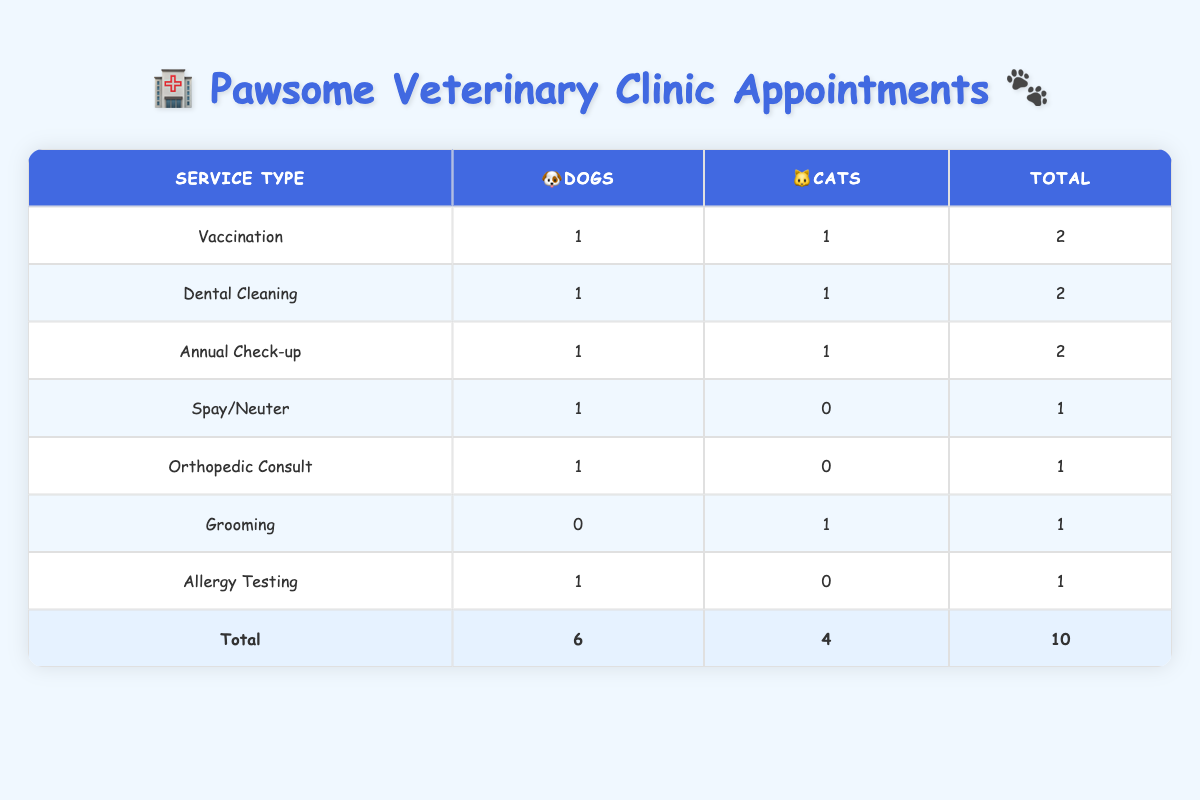What is the total number of appointments for dogs? To find the total number of appointments for dogs, I observe the 'Dogs' column in each row of the table. By summing the values of the 'Dogs' column: 1 (Vaccination) + 1 (Annual Check-up) + 1 (Spay/Neuter) + 1 (Orthopedic Consult) + 1 (Allergy Testing) = 5.
Answer: 5 How many cats had dental cleaning appointments? I look at the 'Cats' column specifically for the 'Dental Cleaning' row in the table. It shows 1 appointment for cats under that service type.
Answer: 1 What is the service type with the highest number of total appointments? I check each service type and their total appointments in the 'Total' column. Both 'Vaccination', 'Dental Cleaning', and 'Annual Check-up' have 2 total appointments each. Since they are tied, I note that these services share the highest count.
Answer: Vaccination, Dental Cleaning, Annual Check-up Are there any pets that received Orthopedic Consults? I check the 'Orthopedic Consult' row in the table and see that there is 1 appointment listed for dogs. Therefore, the answer is yes; there is a pet that received this service.
Answer: Yes What is the average number of appointments for cats? I calculate the total number of cat appointments, which is 4 (from the 'Cats' column), and divide it by the number of different service types provided for cats (which is 4). Therefore, the average is 4/4 = 1.
Answer: 1 How many more dog appointments were there compared to cat appointments? I find the total dog appointments, which is 6, and the total cat appointments, which is 4. Then, I subtract the cat appointments from dog appointments: 6 - 4 = 2.
Answer: 2 Which veterinarian provided the most services? I examine each veterinarian's involvement. Dr. Sarah Johnson has handled 3 appointments, while each of the other veterinarians (Dr. Michael Chen, Dr. Robert Davis, and Dr. Emily Wilson) have 2. Therefore, Dr. Sarah Johnson has provided the most services.
Answer: Dr. Sarah Johnson Is there any grooming service provided for dogs? I see in the 'Grooming' row that the 'Dogs' column shows 0. Thus, no grooming service was provided for dogs.
Answer: No What percentage of total appointments were for spay/neuter services? The total number of appointments is 10, and there is 1 spay/neuter appointment. Therefore, the percentage is (1/10) * 100 = 10%.
Answer: 10% 